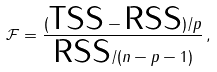<formula> <loc_0><loc_0><loc_500><loc_500>\mathcal { F } = \frac { ( \text {TSS} - \text {RSS} ) / p } { \text {RSS} / ( n - p - 1 ) } \, ,</formula> 